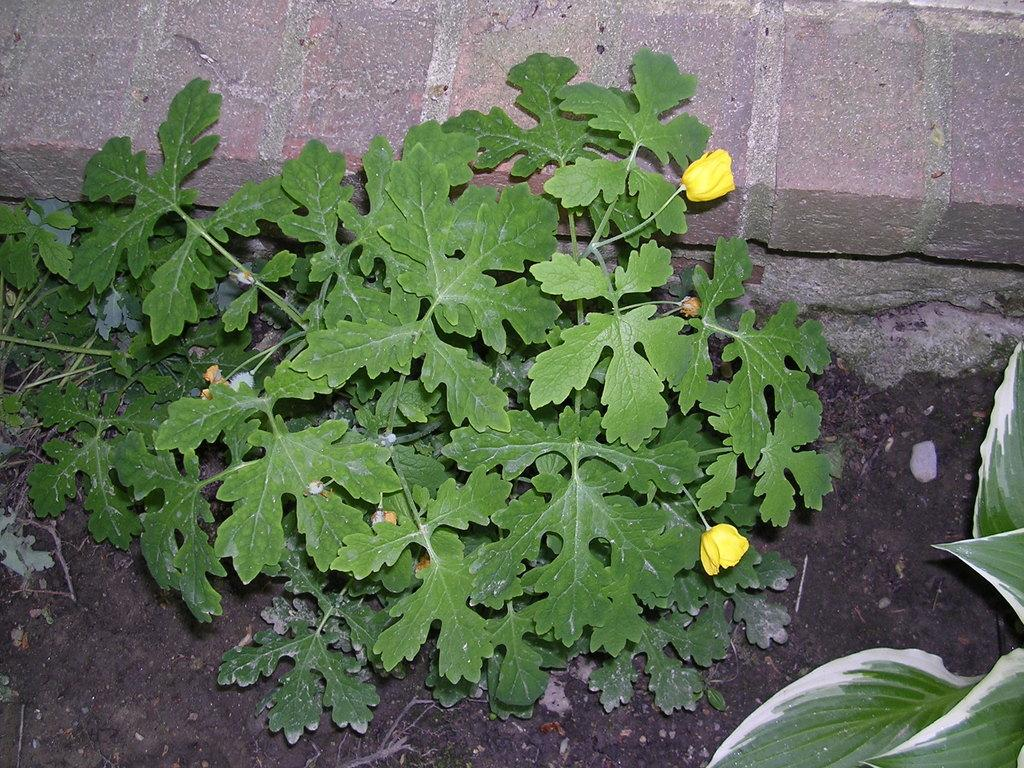What types of vegetation can be seen in the image? There are plants and flowers in the image. Where are the leaves located in the image? The leaves are on the right side of the image. What type of nail is being used to hold the flowers in the image? There is no nail present in the image; the flowers are not attached to anything. 